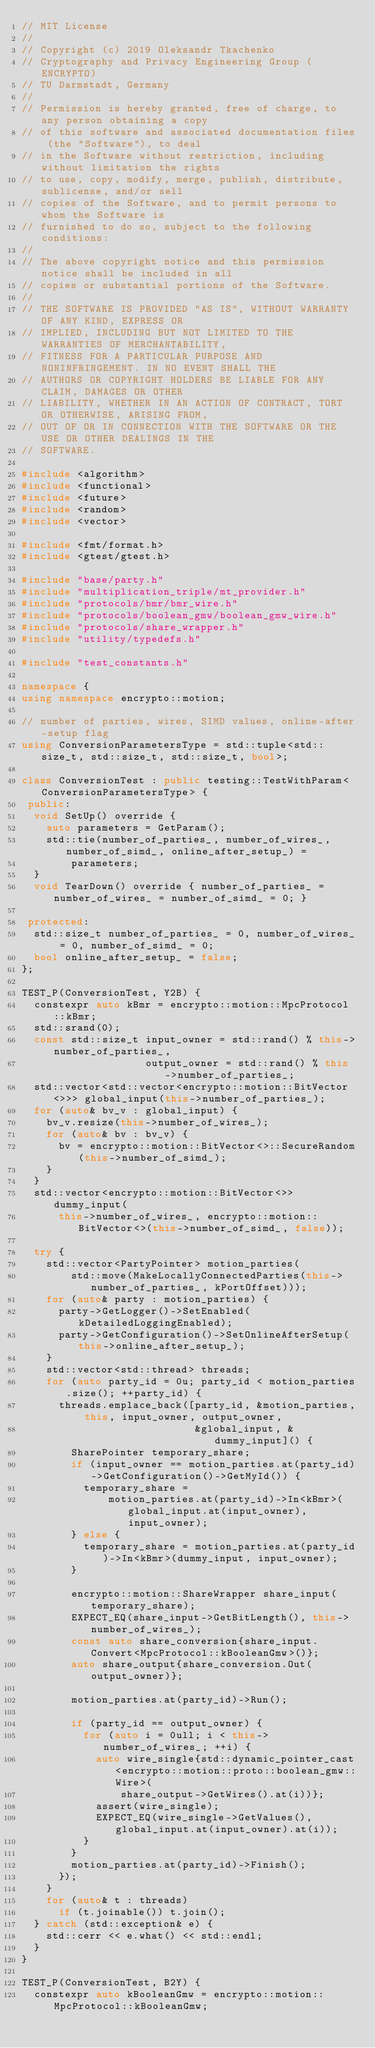Convert code to text. <code><loc_0><loc_0><loc_500><loc_500><_C++_>// MIT License
//
// Copyright (c) 2019 Oleksandr Tkachenko
// Cryptography and Privacy Engineering Group (ENCRYPTO)
// TU Darmstadt, Germany
//
// Permission is hereby granted, free of charge, to any person obtaining a copy
// of this software and associated documentation files (the "Software"), to deal
// in the Software without restriction, including without limitation the rights
// to use, copy, modify, merge, publish, distribute, sublicense, and/or sell
// copies of the Software, and to permit persons to whom the Software is
// furnished to do so, subject to the following conditions:
//
// The above copyright notice and this permission notice shall be included in all
// copies or substantial portions of the Software.
//
// THE SOFTWARE IS PROVIDED "AS IS", WITHOUT WARRANTY OF ANY KIND, EXPRESS OR
// IMPLIED, INCLUDING BUT NOT LIMITED TO THE WARRANTIES OF MERCHANTABILITY,
// FITNESS FOR A PARTICULAR PURPOSE AND NONINFRINGEMENT. IN NO EVENT SHALL THE
// AUTHORS OR COPYRIGHT HOLDERS BE LIABLE FOR ANY CLAIM, DAMAGES OR OTHER
// LIABILITY, WHETHER IN AN ACTION OF CONTRACT, TORT OR OTHERWISE, ARISING FROM,
// OUT OF OR IN CONNECTION WITH THE SOFTWARE OR THE USE OR OTHER DEALINGS IN THE
// SOFTWARE.

#include <algorithm>
#include <functional>
#include <future>
#include <random>
#include <vector>

#include <fmt/format.h>
#include <gtest/gtest.h>

#include "base/party.h"
#include "multiplication_triple/mt_provider.h"
#include "protocols/bmr/bmr_wire.h"
#include "protocols/boolean_gmw/boolean_gmw_wire.h"
#include "protocols/share_wrapper.h"
#include "utility/typedefs.h"

#include "test_constants.h"

namespace {
using namespace encrypto::motion;

// number of parties, wires, SIMD values, online-after-setup flag
using ConversionParametersType = std::tuple<std::size_t, std::size_t, std::size_t, bool>;

class ConversionTest : public testing::TestWithParam<ConversionParametersType> {
 public:
  void SetUp() override {
    auto parameters = GetParam();
    std::tie(number_of_parties_, number_of_wires_, number_of_simd_, online_after_setup_) =
        parameters;
  }
  void TearDown() override { number_of_parties_ = number_of_wires_ = number_of_simd_ = 0; }

 protected:
  std::size_t number_of_parties_ = 0, number_of_wires_ = 0, number_of_simd_ = 0;
  bool online_after_setup_ = false;
};

TEST_P(ConversionTest, Y2B) {
  constexpr auto kBmr = encrypto::motion::MpcProtocol::kBmr;
  std::srand(0);
  const std::size_t input_owner = std::rand() % this->number_of_parties_,
                    output_owner = std::rand() % this->number_of_parties_;
  std::vector<std::vector<encrypto::motion::BitVector<>>> global_input(this->number_of_parties_);
  for (auto& bv_v : global_input) {
    bv_v.resize(this->number_of_wires_);
    for (auto& bv : bv_v) {
      bv = encrypto::motion::BitVector<>::SecureRandom(this->number_of_simd_);
    }
  }
  std::vector<encrypto::motion::BitVector<>> dummy_input(
      this->number_of_wires_, encrypto::motion::BitVector<>(this->number_of_simd_, false));

  try {
    std::vector<PartyPointer> motion_parties(
        std::move(MakeLocallyConnectedParties(this->number_of_parties_, kPortOffset)));
    for (auto& party : motion_parties) {
      party->GetLogger()->SetEnabled(kDetailedLoggingEnabled);
      party->GetConfiguration()->SetOnlineAfterSetup(this->online_after_setup_);
    }
    std::vector<std::thread> threads;
    for (auto party_id = 0u; party_id < motion_parties.size(); ++party_id) {
      threads.emplace_back([party_id, &motion_parties, this, input_owner, output_owner,
                            &global_input, &dummy_input]() {
        SharePointer temporary_share;
        if (input_owner == motion_parties.at(party_id)->GetConfiguration()->GetMyId()) {
          temporary_share =
              motion_parties.at(party_id)->In<kBmr>(global_input.at(input_owner), input_owner);
        } else {
          temporary_share = motion_parties.at(party_id)->In<kBmr>(dummy_input, input_owner);
        }

        encrypto::motion::ShareWrapper share_input(temporary_share);
        EXPECT_EQ(share_input->GetBitLength(), this->number_of_wires_);
        const auto share_conversion{share_input.Convert<MpcProtocol::kBooleanGmw>()};
        auto share_output{share_conversion.Out(output_owner)};

        motion_parties.at(party_id)->Run();

        if (party_id == output_owner) {
          for (auto i = 0ull; i < this->number_of_wires_; ++i) {
            auto wire_single{std::dynamic_pointer_cast<encrypto::motion::proto::boolean_gmw::Wire>(
                share_output->GetWires().at(i))};
            assert(wire_single);
            EXPECT_EQ(wire_single->GetValues(), global_input.at(input_owner).at(i));
          }
        }
        motion_parties.at(party_id)->Finish();
      });
    }
    for (auto& t : threads)
      if (t.joinable()) t.join();
  } catch (std::exception& e) {
    std::cerr << e.what() << std::endl;
  }
}

TEST_P(ConversionTest, B2Y) {
  constexpr auto kBooleanGmw = encrypto::motion::MpcProtocol::kBooleanGmw;</code> 